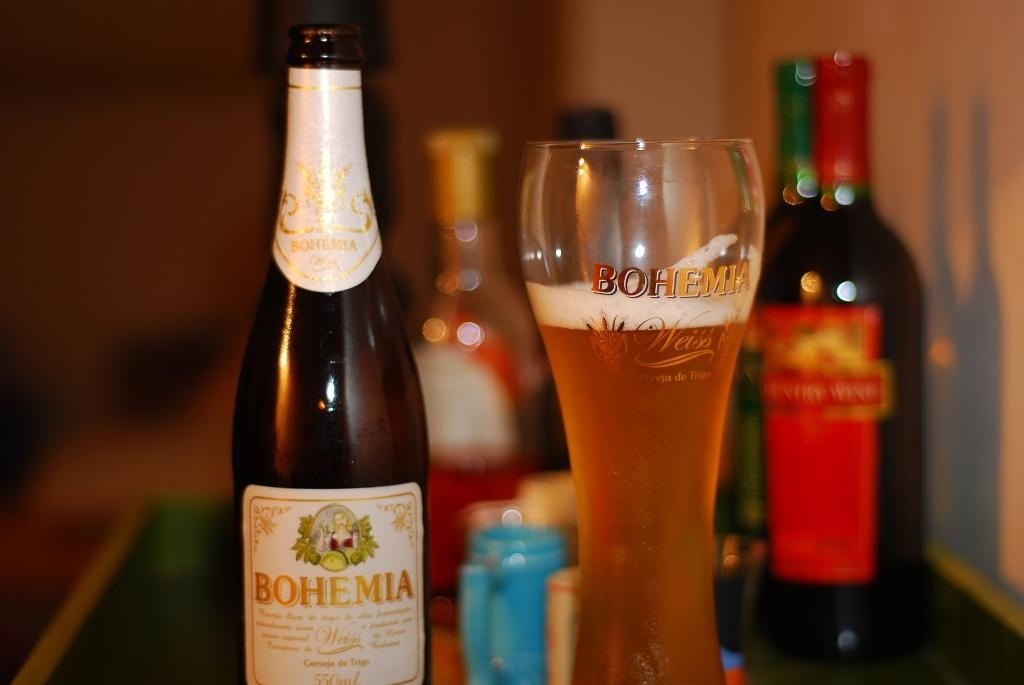<image>
Summarize the visual content of the image. a bottle of bohemia is sitting beside a glass of it 